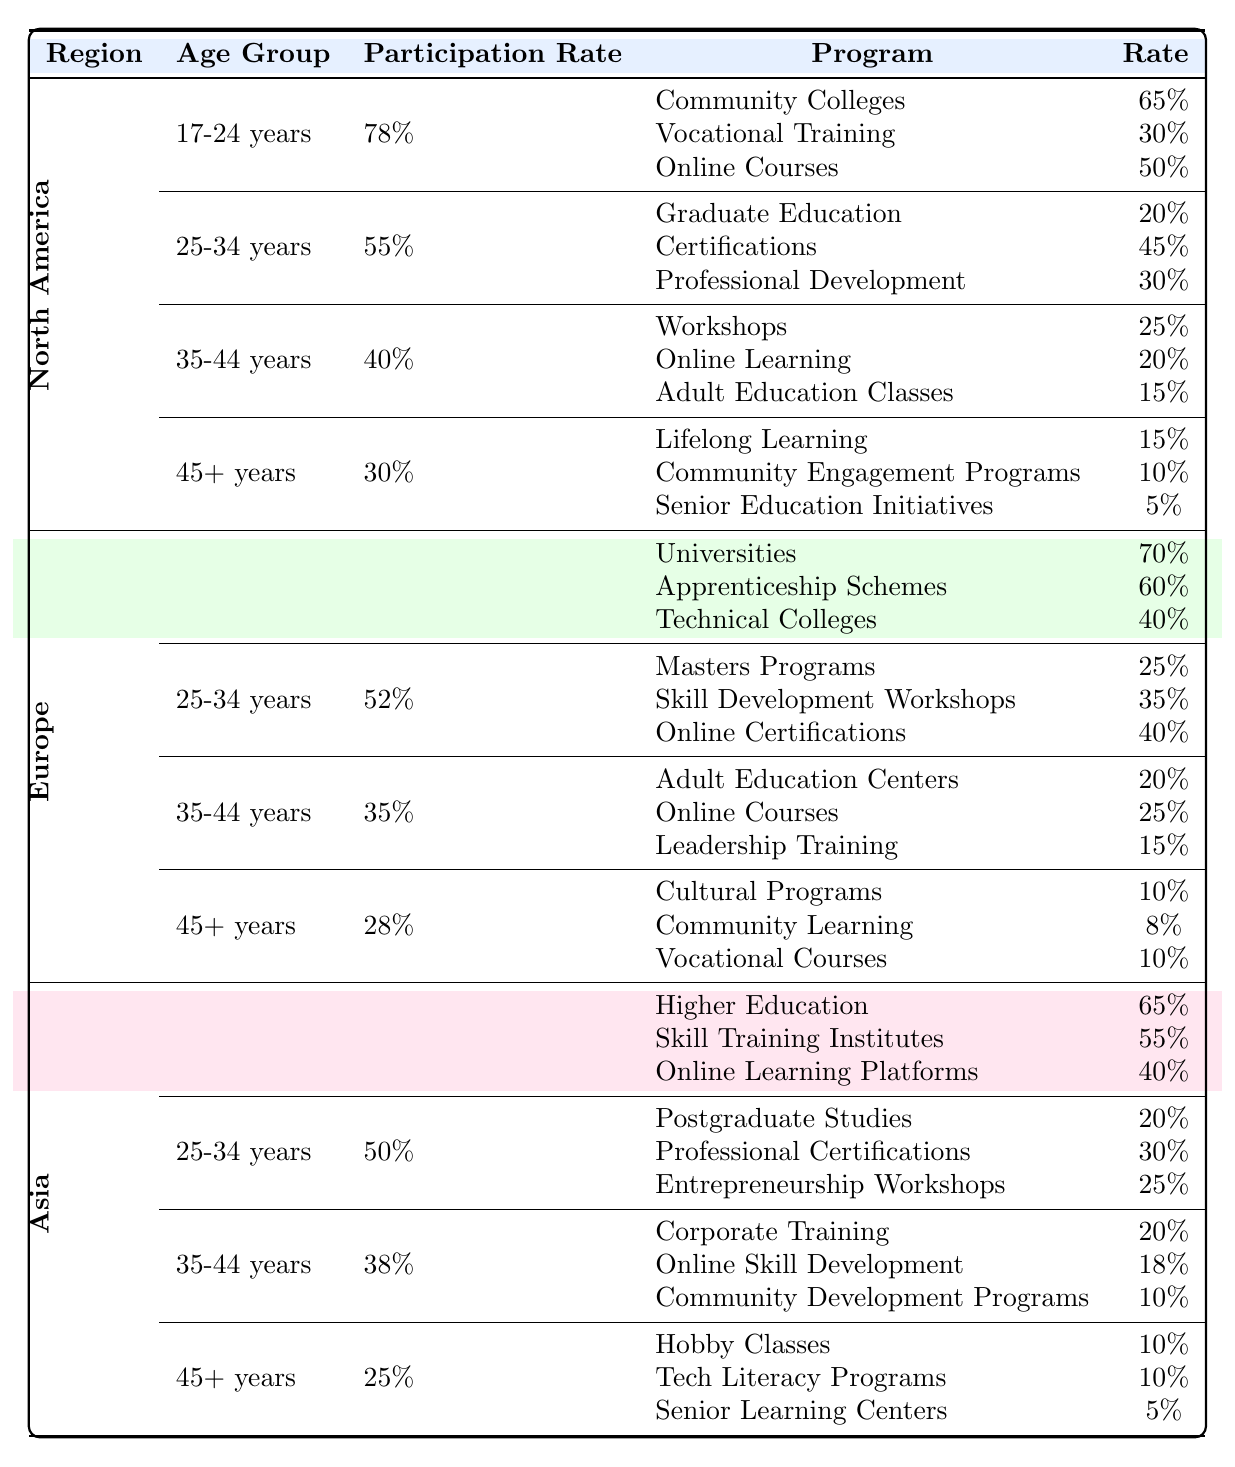What is the participation rate for the 25-34 age group in Asia? From the Asia section of the table, the participation rate for the 25-34 age group is listed as 50%.
Answer: 50% Which program has the highest participation rate in North America for the 17-24 age group? In North America for the 17-24 age group, the Community Colleges program has the highest participation rate at 65%.
Answer: Community Colleges What is the average participation rate for the 45+ age group across all regions? The participation rates for the 45+ age group are as follows: North America at 30%, Europe at 28%, and Asia at 25%. The average is calculated as (30 + 28 + 25) / 3 = 27.67%.
Answer: 27.67% Is the participation rate for the 17-24 age group in Europe greater than that in North America? The participation rate for the 17-24 age group in Europe is 80%, while in North America it is 78%. Therefore, it is true that Europe's rate is higher.
Answer: Yes Which region has the lowest participation rate for the 35-44 age group, and what is the rate? Comparing the rates for the 35-44 age group: North America is 40%, Europe is 35%, and Asia is 38%. Europe has the lowest participation rate at 35%.
Answer: Europe, 35% What is the total participation rate of vocational training programs in North America for all age groups? The vocational training program participation is as follows for North America: 30% for the 17-24 age group, 0% for 25-34, 0% for 35-44, and 0% for 45+. Totaling gives 30%.
Answer: 30% How does the participation rate for vocational courses in Europe compare to that in Asia for the 45+ age group? In Europe, the rate for vocational courses is 10%, while in Asia it is also 10%. Since both rates are equal, they are the same.
Answer: They are equal What is the difference in participation rates for online learning programs between the 34-44 age group in North America and Asia? In North America, the online learning participation rate for the 35-44 age group is 20%, and in Asia, it is 18%. The difference is calculated as 20 - 18 = 2%.
Answer: 2% 